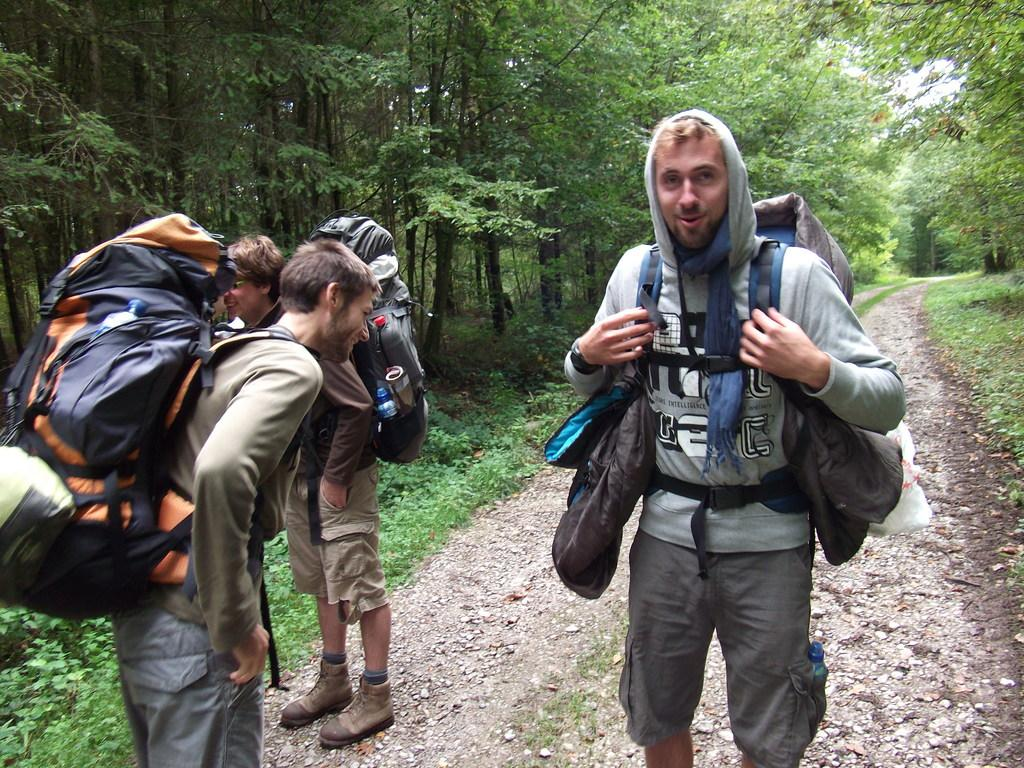How many people are present in the image? There are three people in the image. Where are the people located in the image? The people are standing on the road. What are the people wearing that are visible in the image? The people are wearing bags. What can be seen in the background of the image? There are trees and the sky visible in the background of the image. What type of dog is visible in the image? There is no dog present in the image. How many hands can be seen holding the bags in the image? The image does not show the people's hands, only their bodies and the bags they are wearing. 